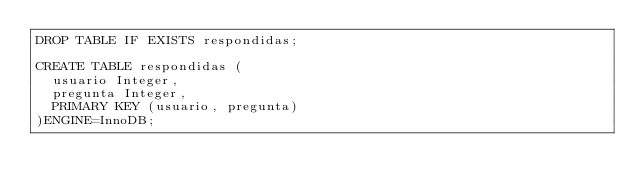<code> <loc_0><loc_0><loc_500><loc_500><_SQL_>DROP TABLE IF EXISTS respondidas;

CREATE TABLE respondidas (
  usuario Integer,
  pregunta Integer,
  PRIMARY KEY (usuario, pregunta)
)ENGINE=InnoDB;
</code> 